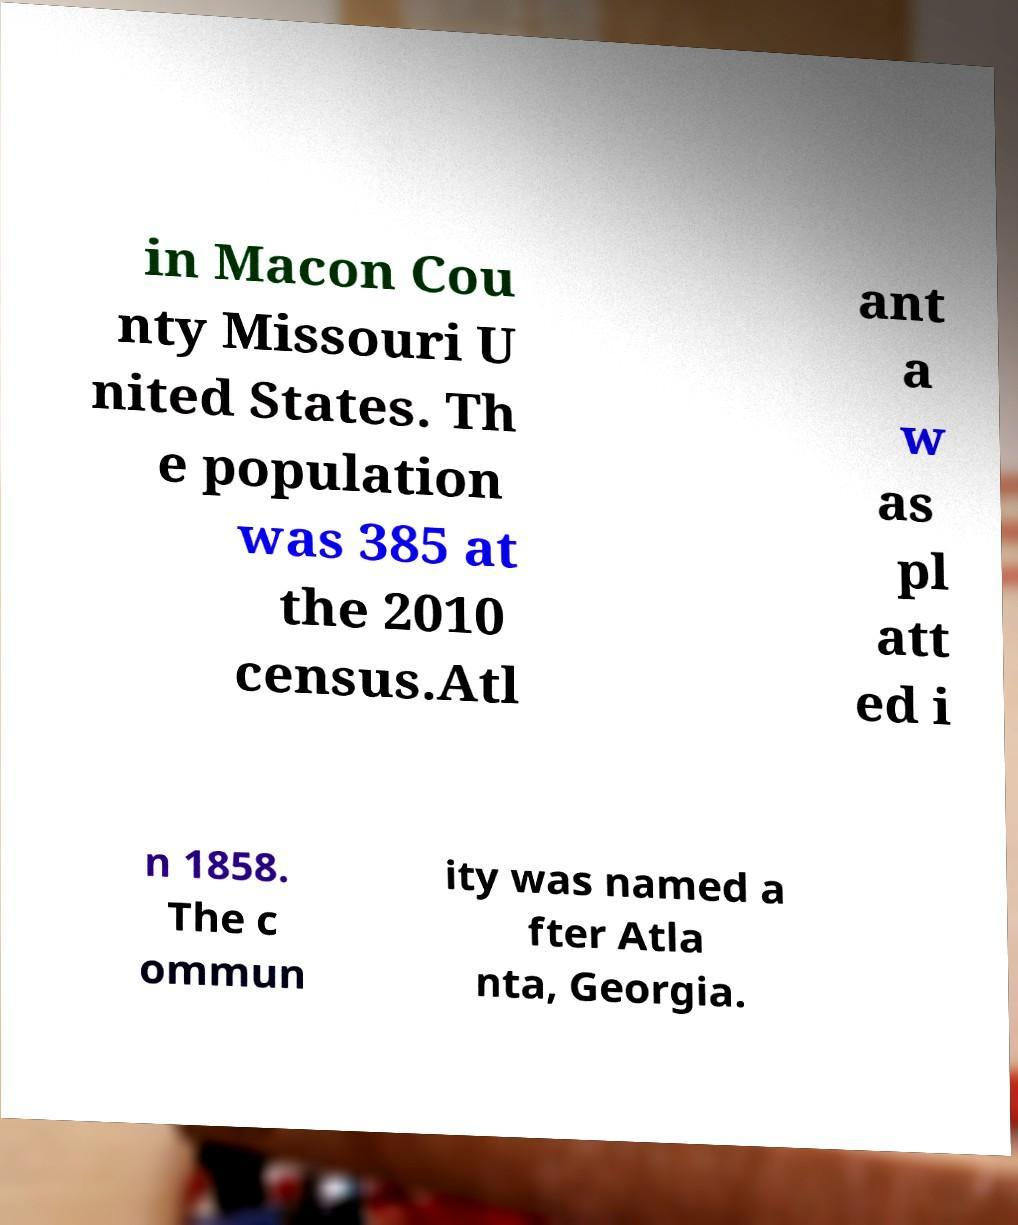Could you extract and type out the text from this image? in Macon Cou nty Missouri U nited States. Th e population was 385 at the 2010 census.Atl ant a w as pl att ed i n 1858. The c ommun ity was named a fter Atla nta, Georgia. 